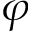Convert formula to latex. <formula><loc_0><loc_0><loc_500><loc_500>\varphi</formula> 